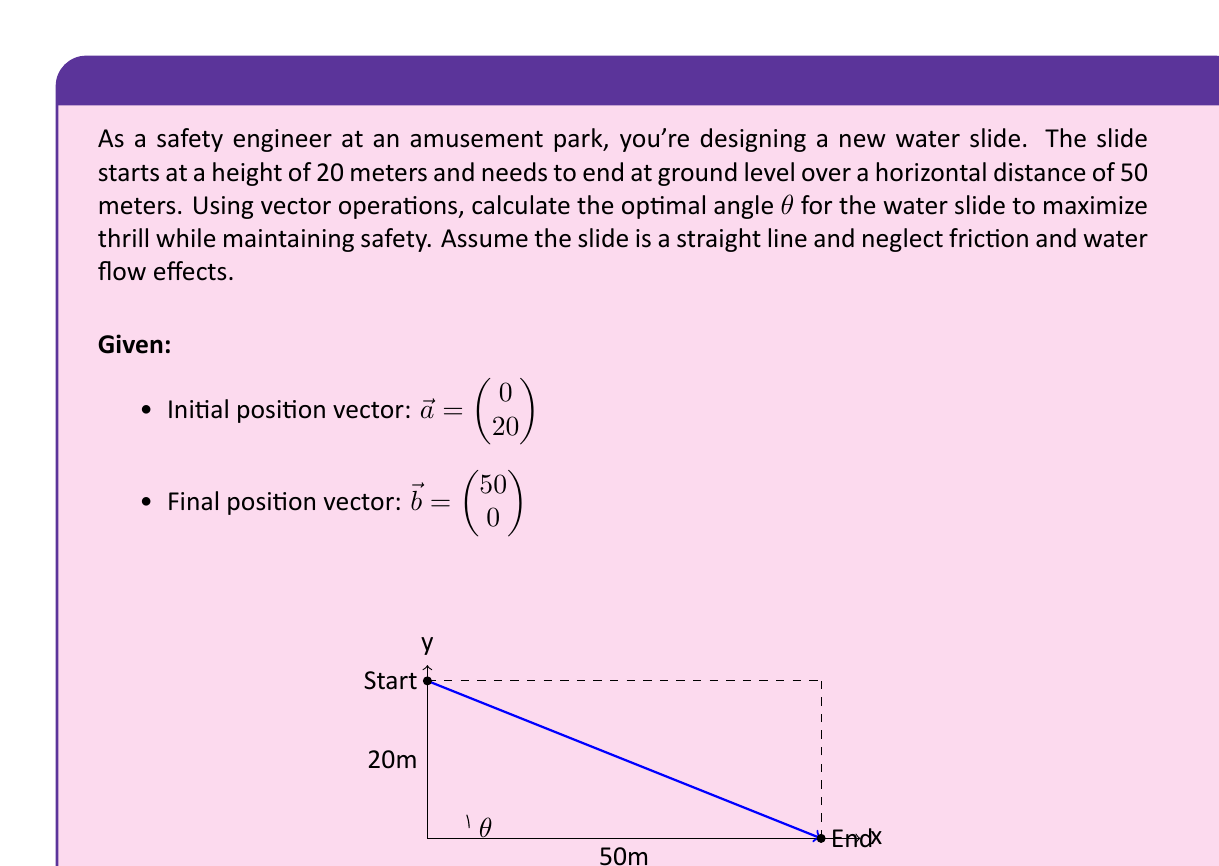Show me your answer to this math problem. To solve this problem, we'll use vector operations to find the angle θ:

1) First, we need to find the displacement vector $\vec{d}$ from the start to the end of the slide:
   $\vec{d} = \vec{b} - \vec{a} = \begin{pmatrix} 50 \\ 0 \end{pmatrix} - \begin{pmatrix} 0 \\ 20 \end{pmatrix} = \begin{pmatrix} 50 \\ -20 \end{pmatrix}$

2) The magnitude of this vector is the length of the slide:
   $|\vec{d}| = \sqrt{50^2 + (-20)^2} = \sqrt{2900} = 10\sqrt{29}$ meters

3) To find the angle θ, we can use the dot product formula:
   $\cos \theta = \frac{\vec{d} \cdot \vec{i}}{|\vec{d}||\vec{i}|}$

   where $\vec{i} = \begin{pmatrix} 1 \\ 0 \end{pmatrix}$ is the unit vector in the x-direction.

4) Calculating the dot product:
   $\vec{d} \cdot \vec{i} = 50(1) + (-20)(0) = 50$

5) Substituting into the formula:
   $\cos \theta = \frac{50}{10\sqrt{29} \cdot 1} = \frac{5}{\sqrt{29}}$

6) Taking the inverse cosine (arccos) of both sides:
   $\theta = \arccos(\frac{5}{\sqrt{29}})$

7) Calculate the result:
   $\theta \approx 0.3805$ radians or $21.80$ degrees
Answer: The optimal angle for the water slide is $\theta = \arccos(\frac{5}{\sqrt{29}}) \approx 21.80°$ 